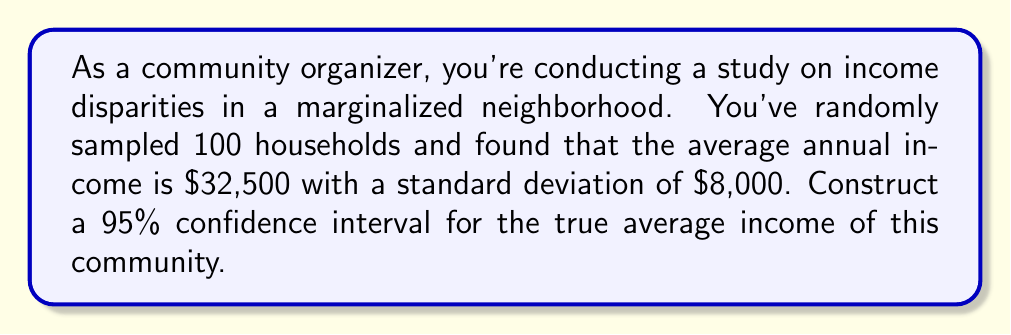Teach me how to tackle this problem. To construct a 95% confidence interval, we'll follow these steps:

1. Identify the relevant information:
   - Sample size: $n = 100$
   - Sample mean: $\bar{x} = \$32,500$
   - Sample standard deviation: $s = \$8,000$
   - Confidence level: 95% (α = 0.05)

2. Find the critical value:
   For a 95% confidence interval, we use z = 1.96 (from the standard normal distribution table).

3. Calculate the margin of error:
   Margin of error = $z \cdot \frac{s}{\sqrt{n}}$
   $$ \text{Margin of error} = 1.96 \cdot \frac{8000}{\sqrt{100}} = 1.96 \cdot 800 = 1568 $$

4. Construct the confidence interval:
   Lower bound = $\bar{x} - \text{margin of error}$
   Upper bound = $\bar{x} + \text{margin of error}$

   $$ \text{Lower bound} = 32500 - 1568 = 30932 $$
   $$ \text{Upper bound} = 32500 + 1568 = 34068 $$

5. Round to the nearest dollar:
   The 95% confidence interval is ($30,932, $34,068).

Interpretation: We can be 95% confident that the true average income for this marginalized community falls between $30,932 and $34,068.
Answer: ($30,932, $34,068) 